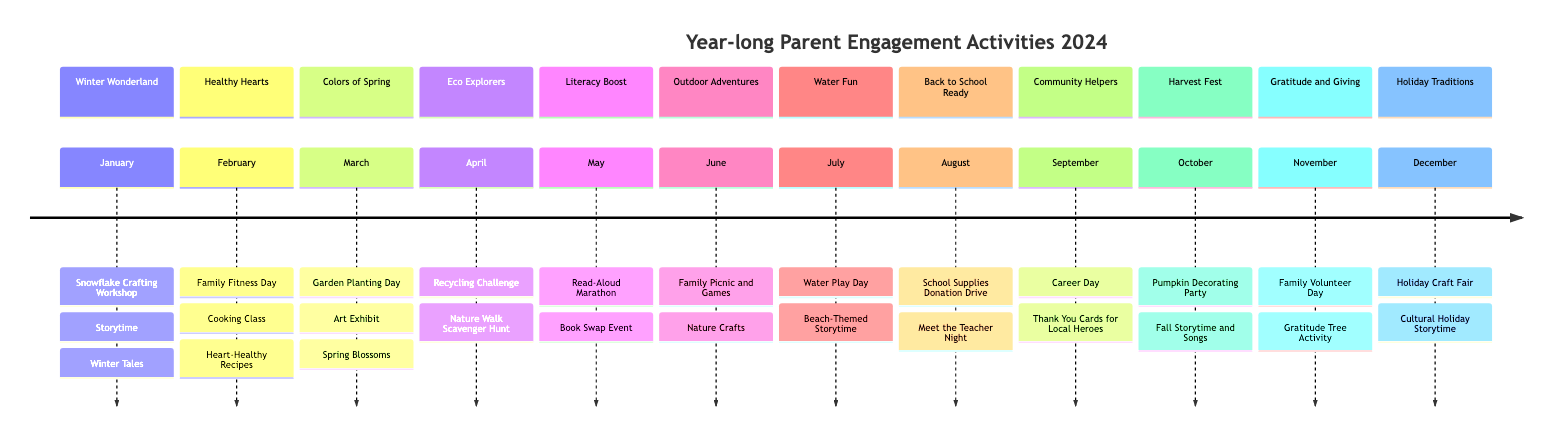What is the theme for March? The diagram indicates that the theme for March is "Colors of Spring." This information is directly listed under the March section of the timeline.
Answer: Colors of Spring How many high participation level activities are there in July? In the July section, there is one activity listed with a high participation level, which is "Water Play Day." This is the only entry categorized under high participation for that month.
Answer: 1 What activity occurs in December? According to the diagram, the activities listed for December are "Holiday Craft Fair" and "Cultural Holiday Storytime." Both activities are mentioned in that month's section.
Answer: Holiday Craft Fair Which month features the theme "Gratitude and Giving"? The timeline displays "Gratitude and Giving" as the theme for November. This is specifically indicated under the November section of the diagram.
Answer: November Which theme has the title "Family Fitness Day"? "Family Fitness Day" is the activity associated with the "Healthy Hearts" theme in February. This activity is specifically mentioned as having a high participation level in that month.
Answer: Healthy Hearts How many months have a "High" participation level activity mentioned? Upon reviewing the timeline, each month from January to December has at least one activity with a high participation level, totaling 12 months. This means every month lists at least one high participation activity.
Answer: 12 What is the participation level for the "Nature Walk Scavenger Hunt"? The "Nature Walk Scavenger Hunt" is listed under the April section with a medium participation level. This is clearly indicated in the parent participation levels for that month.
Answer: Medium In which month does the "Career Day" activity occur? The "Career Day" activity is listed under the September section, which aligns it with the theme "Community Helpers" for that month. This can be found in the relevant part of the timeline.
Answer: September 